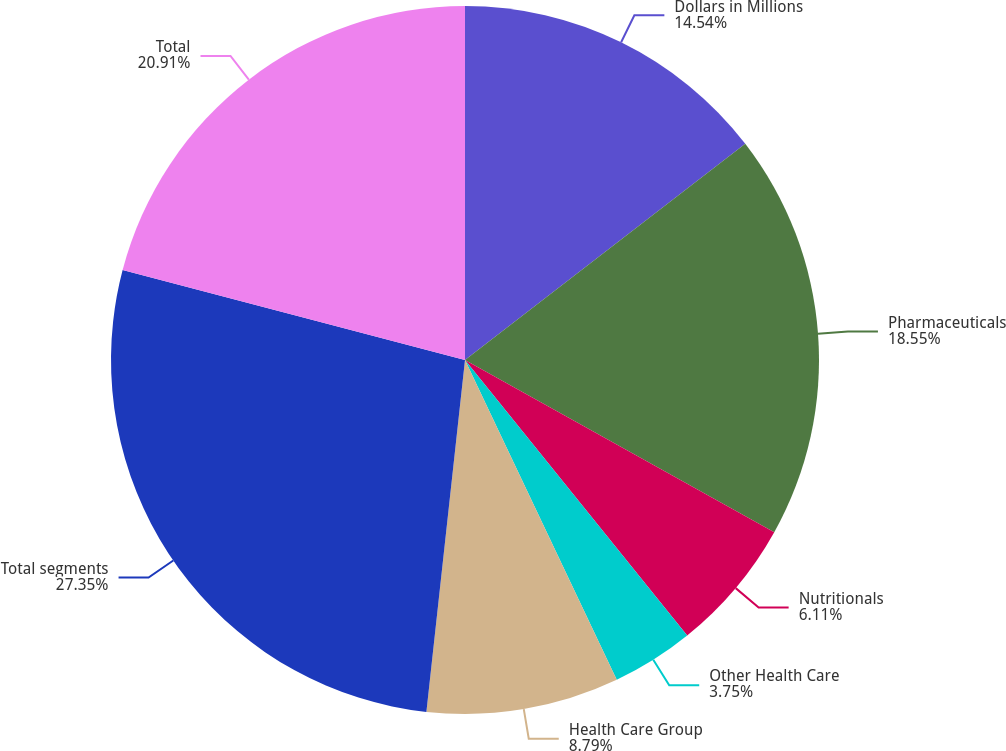Convert chart to OTSL. <chart><loc_0><loc_0><loc_500><loc_500><pie_chart><fcel>Dollars in Millions<fcel>Pharmaceuticals<fcel>Nutritionals<fcel>Other Health Care<fcel>Health Care Group<fcel>Total segments<fcel>Total<nl><fcel>14.54%<fcel>18.55%<fcel>6.11%<fcel>3.75%<fcel>8.79%<fcel>27.35%<fcel>20.91%<nl></chart> 